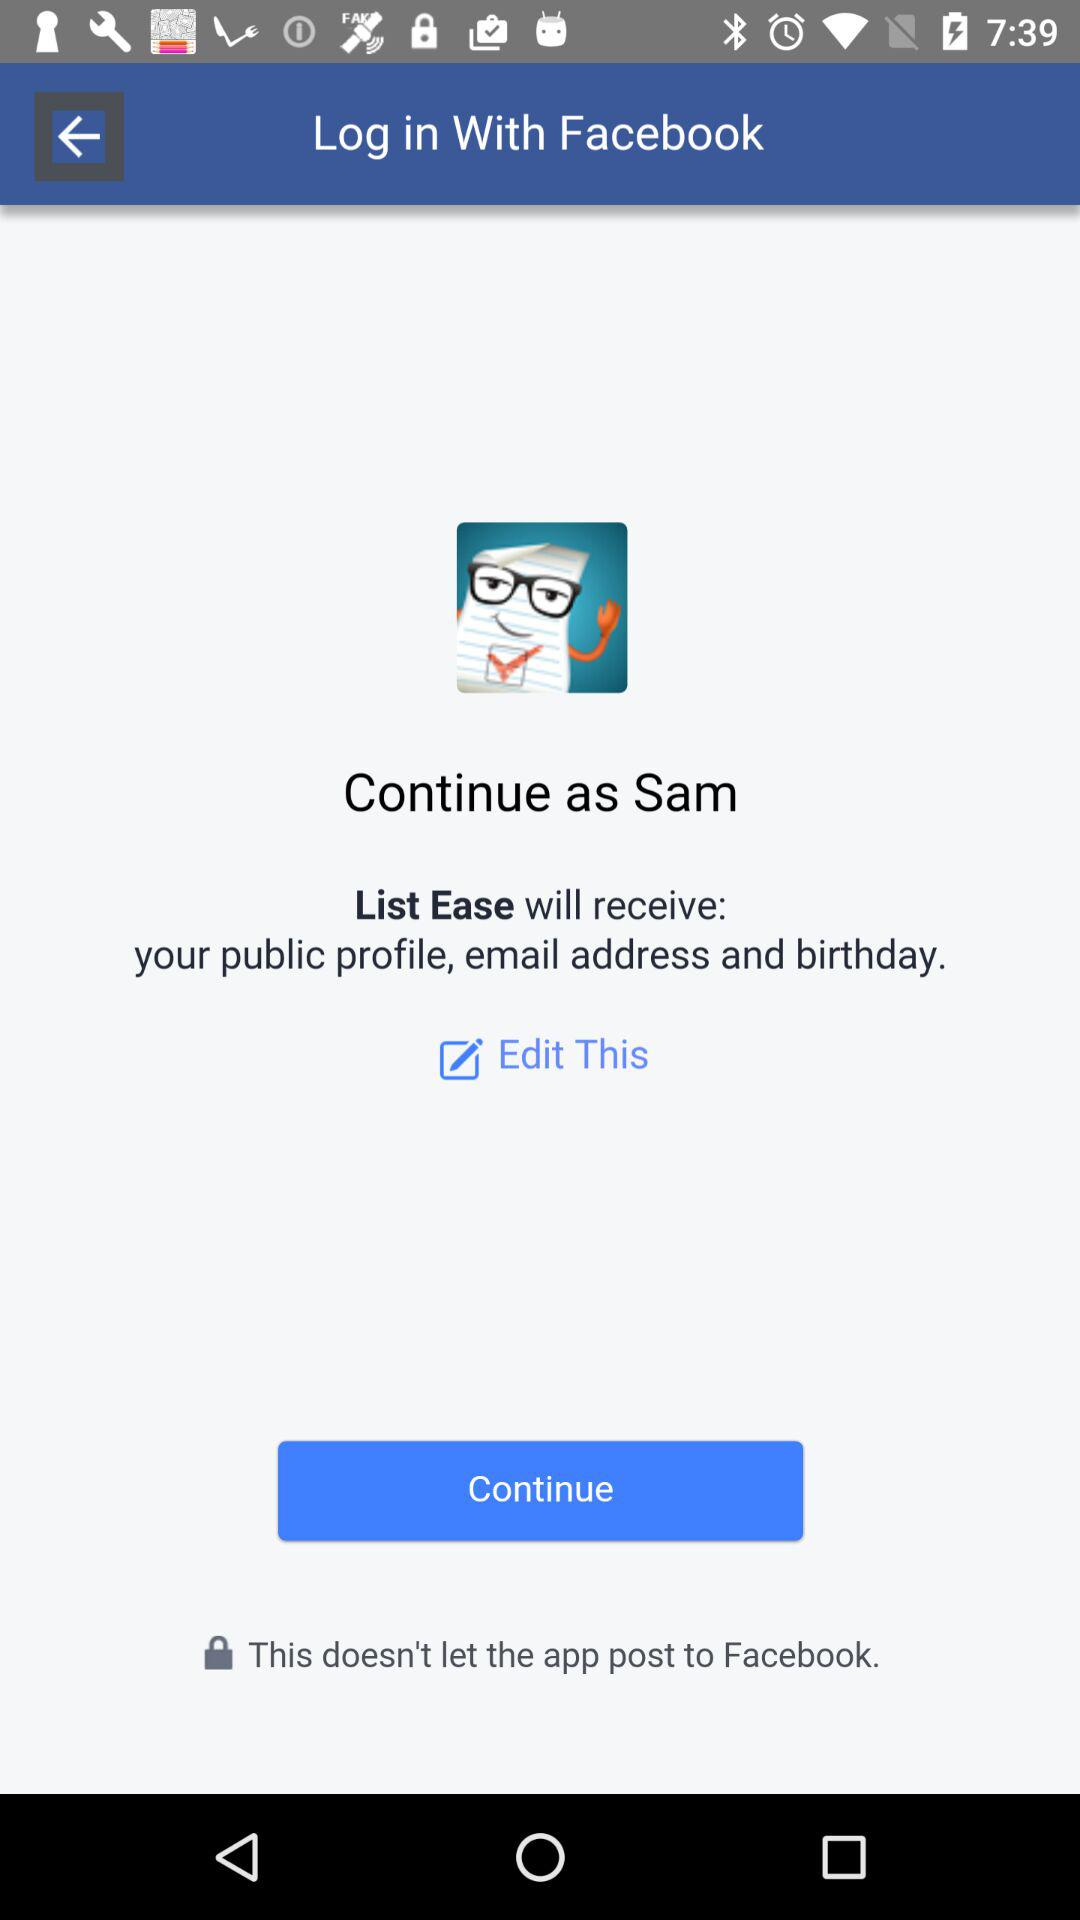What application is asking for permission? The application asking for permission is "List Ease". 